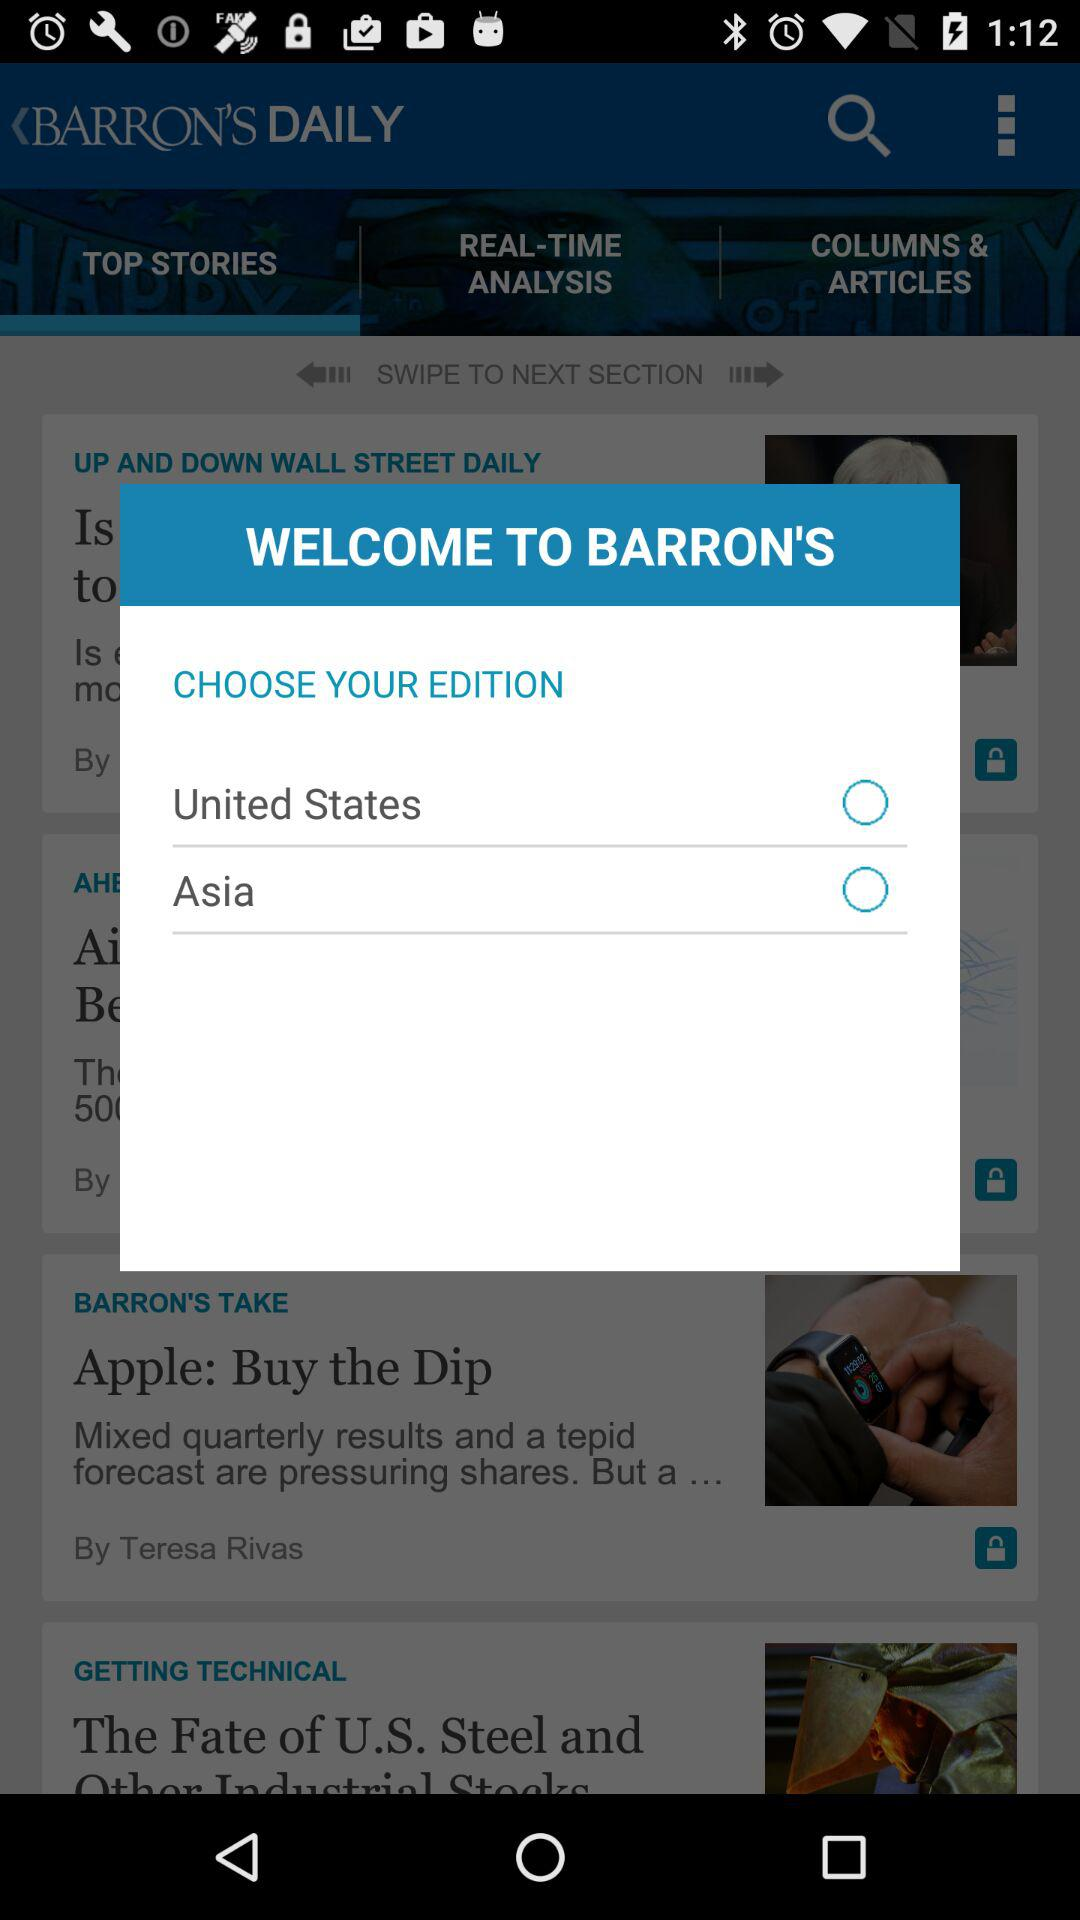What is the name of the application? The name of the application is "BARRON'S". 